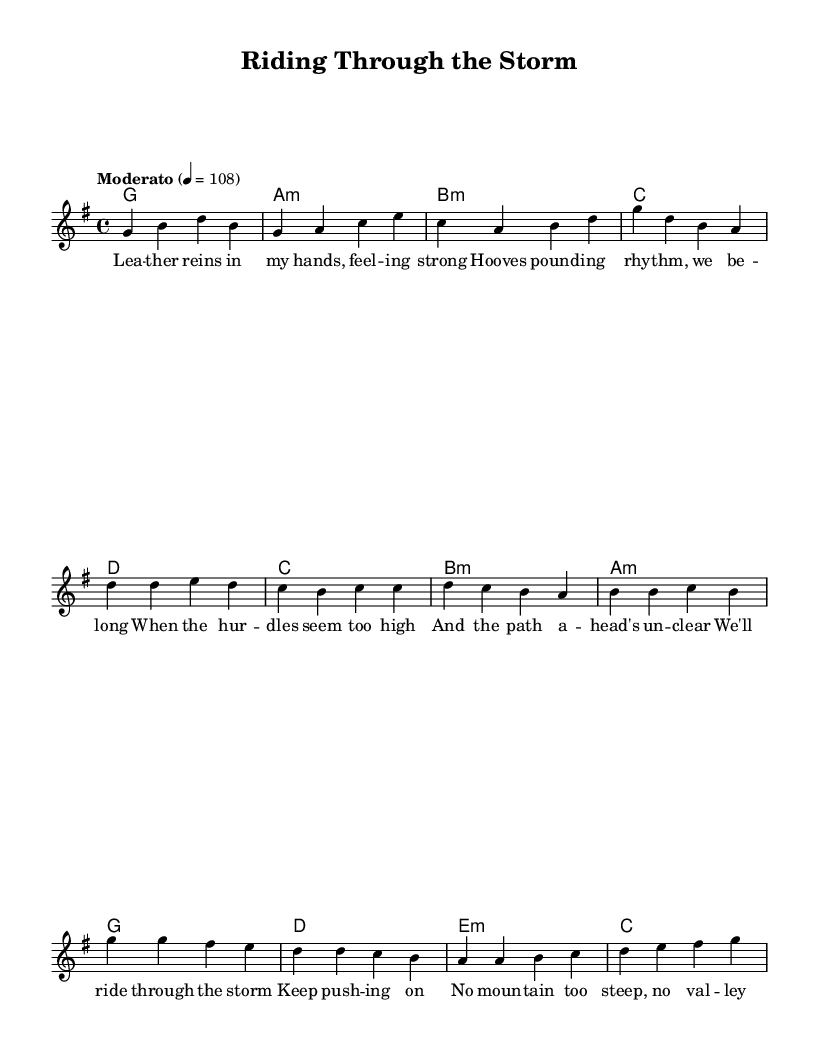What is the key signature of this music? The key signature is G major, which has one sharp (F#). This can be identified by looking at the beginning of the staff where the sharps are indicated.
Answer: G major What is the time signature of this piece? The time signature is 4/4, which means there are four beats in a measure and the quarter note receives one beat. This is evident in the notation displayed at the beginning of the score.
Answer: 4/4 What is the tempo marking for the piece? The tempo marking is "Moderato," indicating a moderate pace, and the associated metronome marking is 108 beats per minute. This is stated at the start of the music.
Answer: Moderato What is the first chord of the song? The first chord listed in the harmonies section is G major, evident in the chord symbols written above the melody, which indicates the harmonic support for the notes.
Answer: G How many measures are there in the chorus section? The chorus consists of four measures, which can be counted from the score where the notes and lyrics for the chorus are grouped, indicating sections separated by bars.
Answer: 4 What lyrical theme is present in the chorus? The lyrical theme revolves around perseverance and determination despite challenges, as suggested by the lines "We'll ride through the storm" and "No mountain too steep." This theme is evident in the content and emotional appeal of the lyrics.
Answer: Perseverance Which part of the song has the lyrics "When the hurdles seem too high"? These lyrics are found in the pre-chorus section, where they address challenges faced during the journey. This can be seen in the alignment of lyrics with the corresponding melody in the pre-chorus written just before the chorus.
Answer: Pre-Chorus 